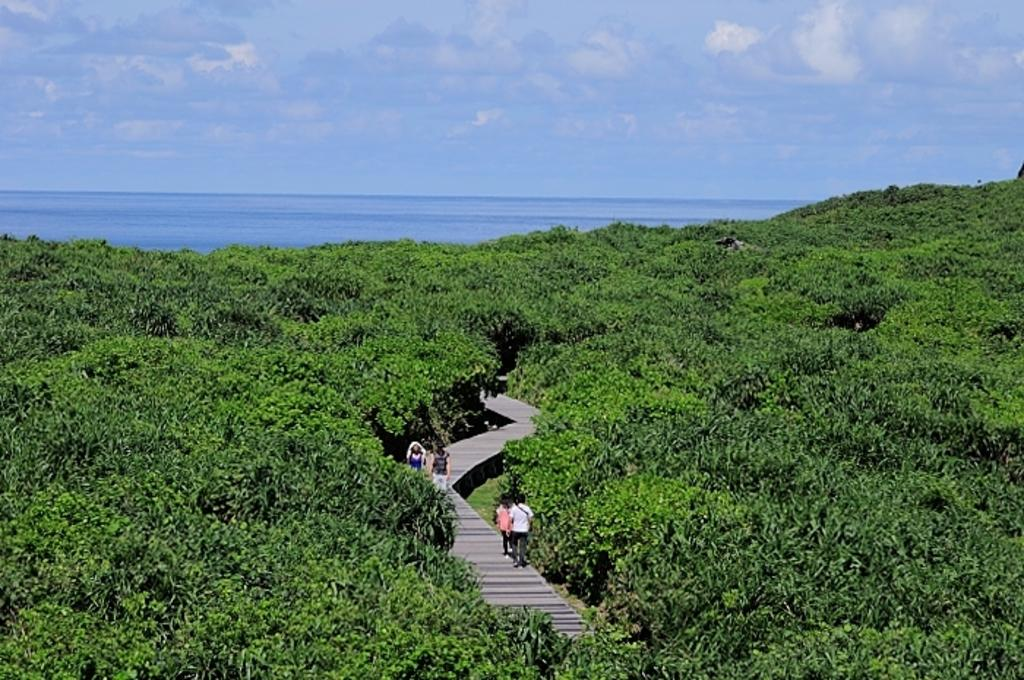What is located in the center of the image? There is a walkway in the center of the image. Can you describe the people visible in the image? There are people visible in the image. What type of vegetation is present in the image? There are trees in the image. What can be seen in the background of the image? There is water and the sky visible in the background of the image. What type of vase is being used to serve the meal in the image? There is no vase or meal present in the image. How does the memory of the walkway affect the people in the image? The image does not provide information about the people's memories or emotions related to the walkway. 